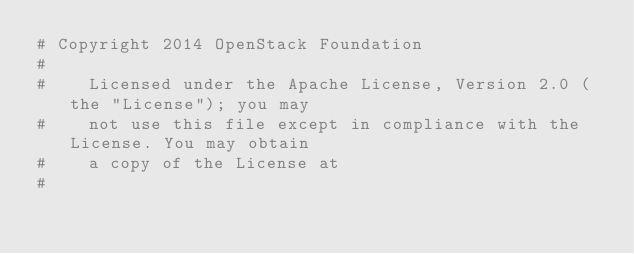<code> <loc_0><loc_0><loc_500><loc_500><_Python_># Copyright 2014 OpenStack Foundation
#
#    Licensed under the Apache License, Version 2.0 (the "License"); you may
#    not use this file except in compliance with the License. You may obtain
#    a copy of the License at
#</code> 